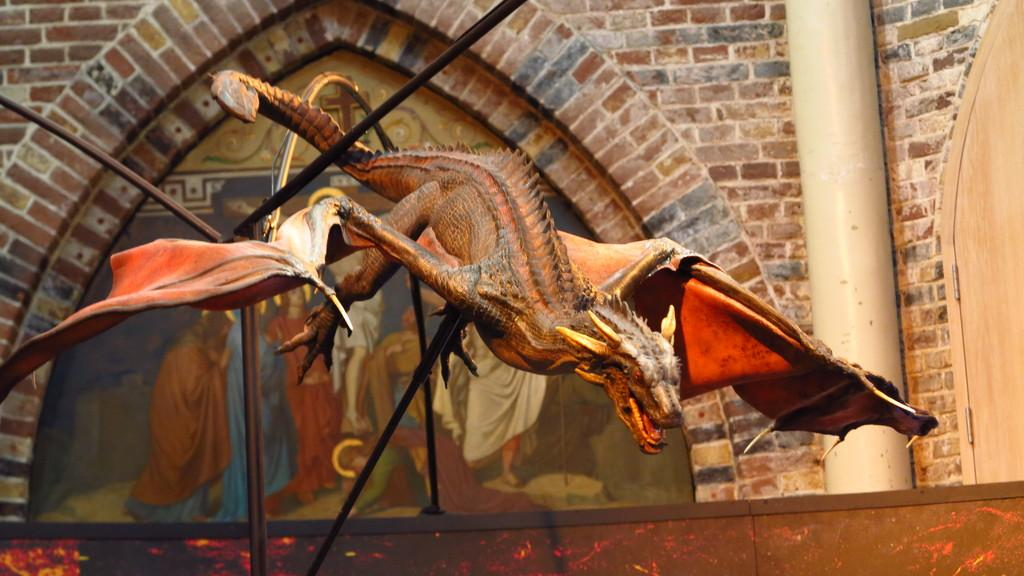What type of object is shaped like a dinosaur in the image? There is a dinosaur-shaped object in the image, but the specific type of object cannot be determined from the facts provided. What can be seen on the wall in the image? There is a photo on a wall in the image. What type of wall is visible on the right side of the image? There is a brick wall on the right side of the image. What type of stocking is hanging from the ceiling in the image? There is no stocking present in the image; it only features a dinosaur-shaped object, a photo on a wall, and a brick wall on the right side. 